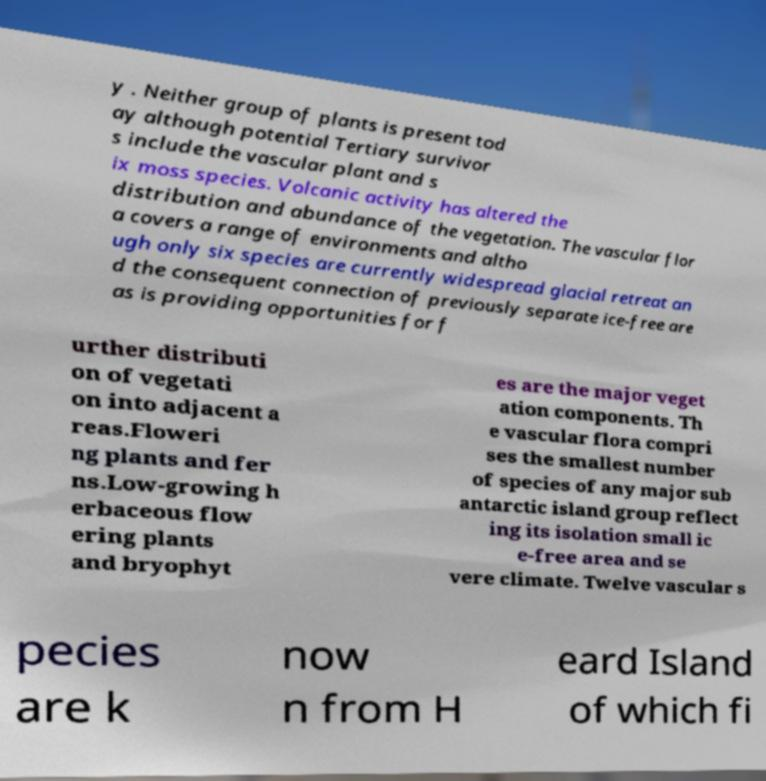What messages or text are displayed in this image? I need them in a readable, typed format. y . Neither group of plants is present tod ay although potential Tertiary survivor s include the vascular plant and s ix moss species. Volcanic activity has altered the distribution and abundance of the vegetation. The vascular flor a covers a range of environments and altho ugh only six species are currently widespread glacial retreat an d the consequent connection of previously separate ice-free are as is providing opportunities for f urther distributi on of vegetati on into adjacent a reas.Floweri ng plants and fer ns.Low-growing h erbaceous flow ering plants and bryophyt es are the major veget ation components. Th e vascular flora compri ses the smallest number of species of any major sub antarctic island group reflect ing its isolation small ic e-free area and se vere climate. Twelve vascular s pecies are k now n from H eard Island of which fi 